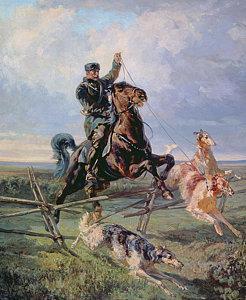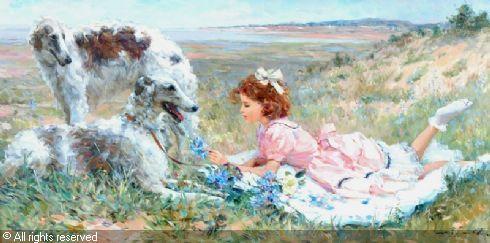The first image is the image on the left, the second image is the image on the right. Considering the images on both sides, is "There is an image with a horse" valid? Answer yes or no. Yes. 